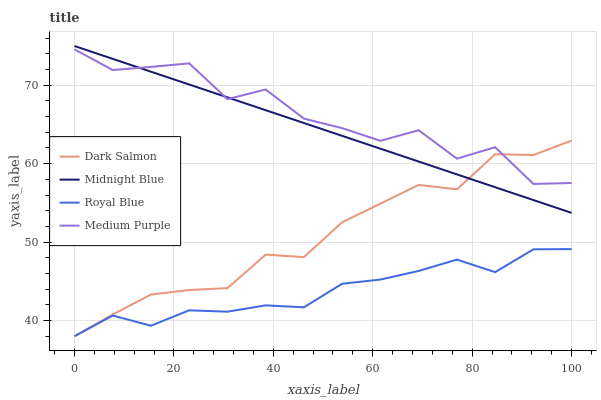Does Royal Blue have the minimum area under the curve?
Answer yes or no. Yes. Does Medium Purple have the maximum area under the curve?
Answer yes or no. Yes. Does Dark Salmon have the minimum area under the curve?
Answer yes or no. No. Does Dark Salmon have the maximum area under the curve?
Answer yes or no. No. Is Midnight Blue the smoothest?
Answer yes or no. Yes. Is Medium Purple the roughest?
Answer yes or no. Yes. Is Royal Blue the smoothest?
Answer yes or no. No. Is Royal Blue the roughest?
Answer yes or no. No. Does Royal Blue have the lowest value?
Answer yes or no. Yes. Does Midnight Blue have the lowest value?
Answer yes or no. No. Does Midnight Blue have the highest value?
Answer yes or no. Yes. Does Dark Salmon have the highest value?
Answer yes or no. No. Is Royal Blue less than Midnight Blue?
Answer yes or no. Yes. Is Medium Purple greater than Royal Blue?
Answer yes or no. Yes. Does Royal Blue intersect Dark Salmon?
Answer yes or no. Yes. Is Royal Blue less than Dark Salmon?
Answer yes or no. No. Is Royal Blue greater than Dark Salmon?
Answer yes or no. No. Does Royal Blue intersect Midnight Blue?
Answer yes or no. No. 